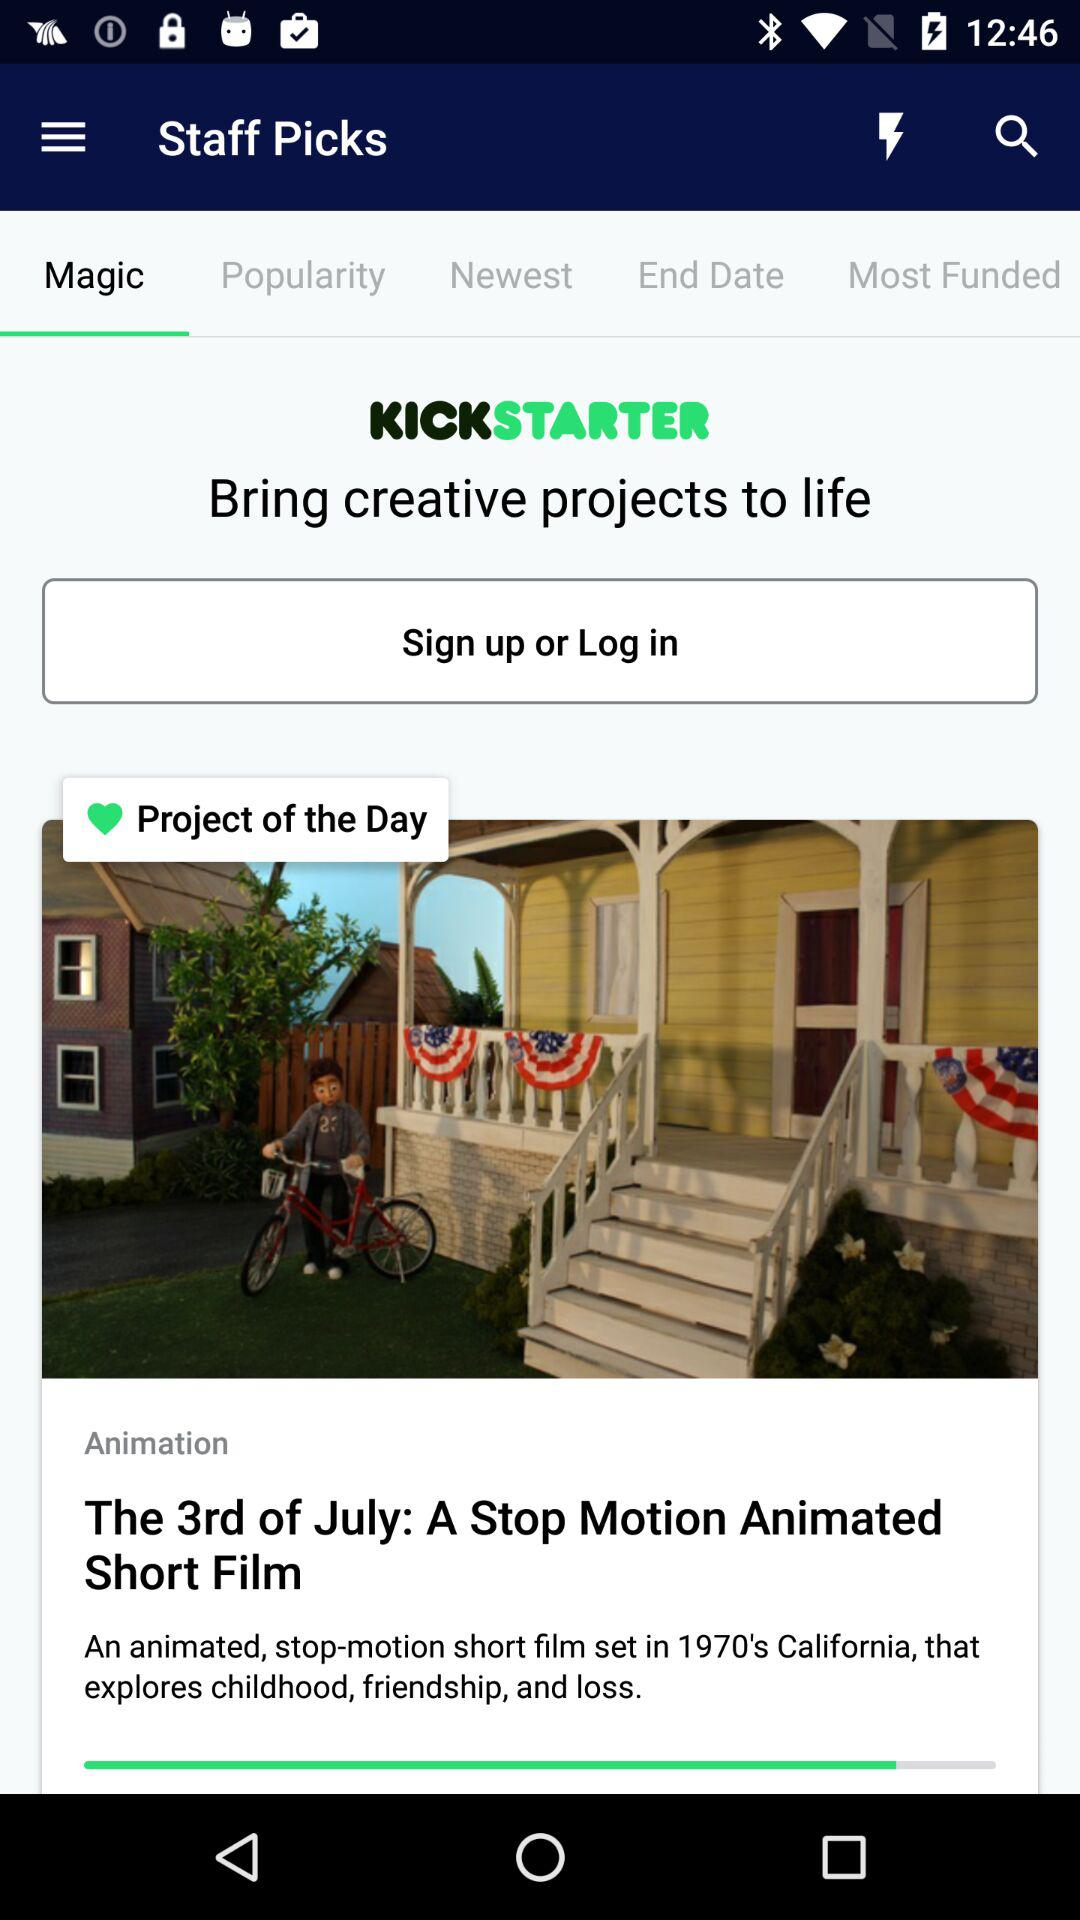What is the application name? The application name is "Staff Picks". 